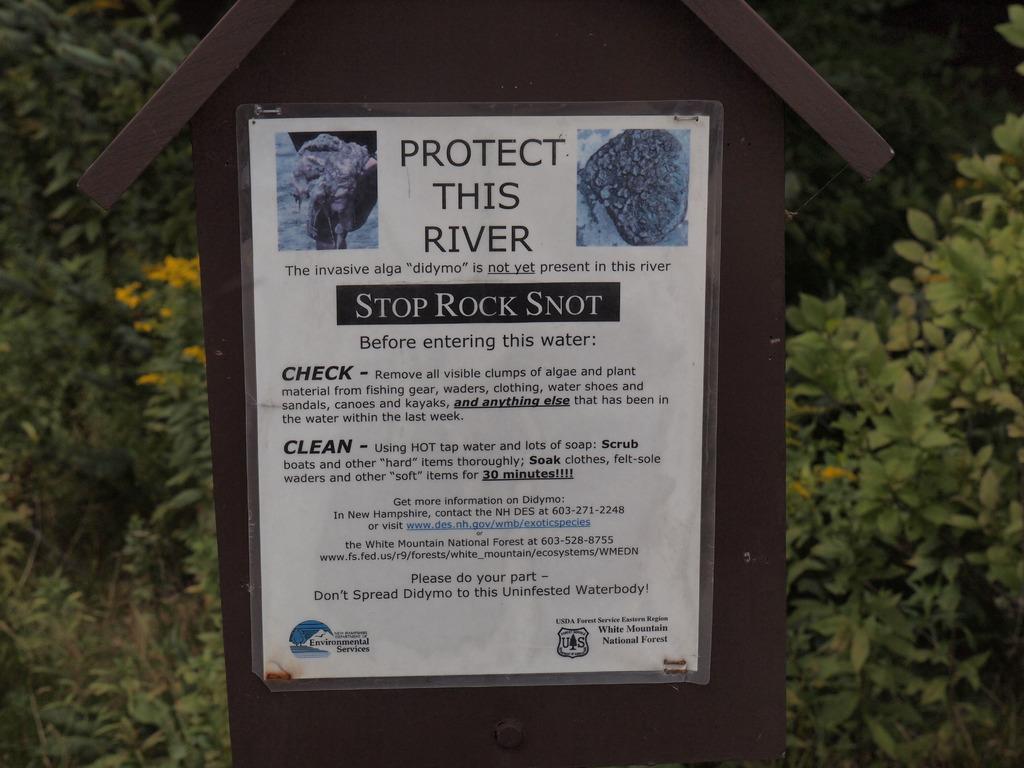Describe this image in one or two sentences. In this image we can see a board with a poster. On the poster there is text and images. In the background we can see trees. 